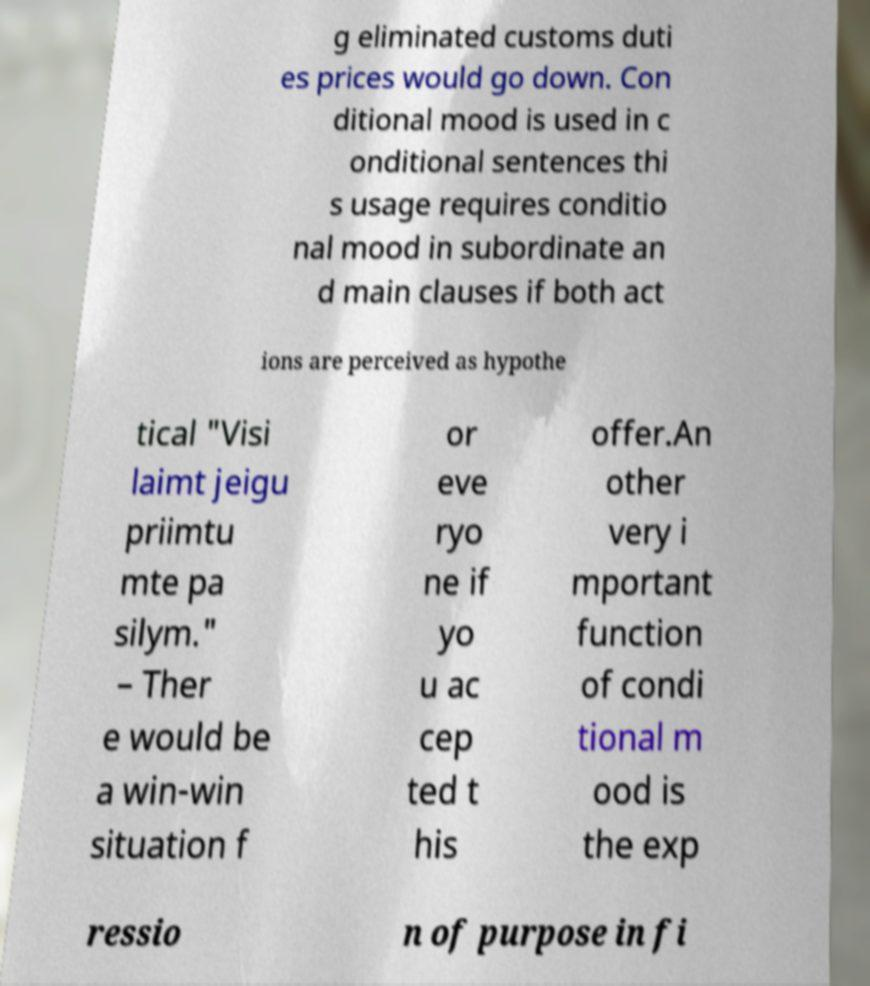For documentation purposes, I need the text within this image transcribed. Could you provide that? g eliminated customs duti es prices would go down. Con ditional mood is used in c onditional sentences thi s usage requires conditio nal mood in subordinate an d main clauses if both act ions are perceived as hypothe tical "Visi laimt jeigu priimtu mte pa silym." – Ther e would be a win-win situation f or eve ryo ne if yo u ac cep ted t his offer.An other very i mportant function of condi tional m ood is the exp ressio n of purpose in fi 